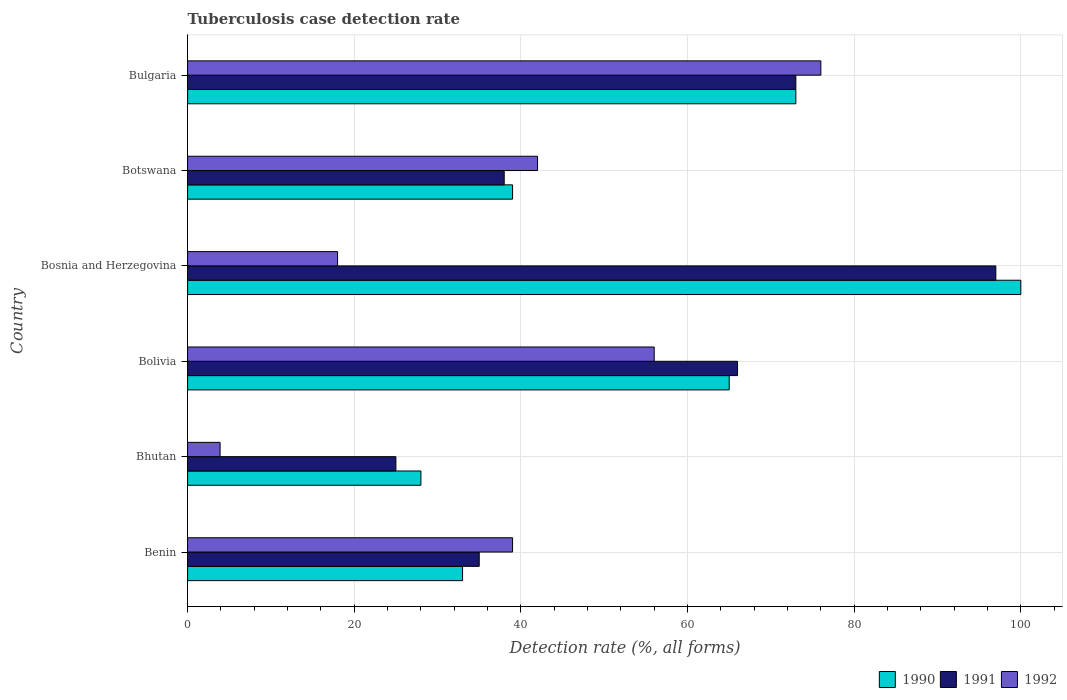How many groups of bars are there?
Provide a short and direct response. 6. Are the number of bars per tick equal to the number of legend labels?
Make the answer very short. Yes. How many bars are there on the 6th tick from the top?
Ensure brevity in your answer.  3. How many bars are there on the 4th tick from the bottom?
Keep it short and to the point. 3. What is the tuberculosis case detection rate in in 1991 in Benin?
Provide a succinct answer. 35. Across all countries, what is the maximum tuberculosis case detection rate in in 1991?
Provide a succinct answer. 97. Across all countries, what is the minimum tuberculosis case detection rate in in 1990?
Your response must be concise. 28. In which country was the tuberculosis case detection rate in in 1990 maximum?
Give a very brief answer. Bosnia and Herzegovina. In which country was the tuberculosis case detection rate in in 1992 minimum?
Offer a terse response. Bhutan. What is the total tuberculosis case detection rate in in 1992 in the graph?
Offer a very short reply. 234.9. What is the difference between the tuberculosis case detection rate in in 1990 in Benin and that in Bosnia and Herzegovina?
Offer a terse response. -67. What is the difference between the tuberculosis case detection rate in in 1991 in Bhutan and the tuberculosis case detection rate in in 1990 in Benin?
Keep it short and to the point. -8. What is the average tuberculosis case detection rate in in 1990 per country?
Your answer should be compact. 56.33. In how many countries, is the tuberculosis case detection rate in in 1990 greater than 56 %?
Keep it short and to the point. 3. What is the ratio of the tuberculosis case detection rate in in 1990 in Benin to that in Bosnia and Herzegovina?
Provide a short and direct response. 0.33. Is the tuberculosis case detection rate in in 1992 in Benin less than that in Botswana?
Provide a short and direct response. Yes. What is the difference between the highest and the second highest tuberculosis case detection rate in in 1990?
Offer a very short reply. 27. What is the difference between the highest and the lowest tuberculosis case detection rate in in 1992?
Provide a short and direct response. 72.1. Is the sum of the tuberculosis case detection rate in in 1991 in Benin and Bosnia and Herzegovina greater than the maximum tuberculosis case detection rate in in 1992 across all countries?
Provide a short and direct response. Yes. How many bars are there?
Your response must be concise. 18. Are all the bars in the graph horizontal?
Provide a short and direct response. Yes. What is the difference between two consecutive major ticks on the X-axis?
Provide a short and direct response. 20. Are the values on the major ticks of X-axis written in scientific E-notation?
Provide a short and direct response. No. How many legend labels are there?
Offer a very short reply. 3. How are the legend labels stacked?
Offer a terse response. Horizontal. What is the title of the graph?
Provide a succinct answer. Tuberculosis case detection rate. Does "1973" appear as one of the legend labels in the graph?
Ensure brevity in your answer.  No. What is the label or title of the X-axis?
Ensure brevity in your answer.  Detection rate (%, all forms). What is the Detection rate (%, all forms) of 1991 in Benin?
Keep it short and to the point. 35. What is the Detection rate (%, all forms) of 1992 in Benin?
Ensure brevity in your answer.  39. What is the Detection rate (%, all forms) in 1990 in Bhutan?
Give a very brief answer. 28. What is the Detection rate (%, all forms) of 1992 in Bolivia?
Offer a terse response. 56. What is the Detection rate (%, all forms) in 1990 in Bosnia and Herzegovina?
Provide a short and direct response. 100. What is the Detection rate (%, all forms) of 1991 in Bosnia and Herzegovina?
Keep it short and to the point. 97. What is the Detection rate (%, all forms) in 1990 in Bulgaria?
Ensure brevity in your answer.  73. What is the Detection rate (%, all forms) in 1991 in Bulgaria?
Offer a very short reply. 73. What is the Detection rate (%, all forms) of 1992 in Bulgaria?
Provide a short and direct response. 76. Across all countries, what is the maximum Detection rate (%, all forms) of 1990?
Provide a succinct answer. 100. Across all countries, what is the maximum Detection rate (%, all forms) in 1991?
Your response must be concise. 97. Across all countries, what is the minimum Detection rate (%, all forms) in 1990?
Offer a terse response. 28. Across all countries, what is the minimum Detection rate (%, all forms) in 1992?
Your answer should be compact. 3.9. What is the total Detection rate (%, all forms) in 1990 in the graph?
Offer a very short reply. 338. What is the total Detection rate (%, all forms) in 1991 in the graph?
Provide a succinct answer. 334. What is the total Detection rate (%, all forms) in 1992 in the graph?
Ensure brevity in your answer.  234.9. What is the difference between the Detection rate (%, all forms) in 1990 in Benin and that in Bhutan?
Your answer should be compact. 5. What is the difference between the Detection rate (%, all forms) of 1992 in Benin and that in Bhutan?
Your answer should be compact. 35.1. What is the difference between the Detection rate (%, all forms) in 1990 in Benin and that in Bolivia?
Offer a very short reply. -32. What is the difference between the Detection rate (%, all forms) of 1991 in Benin and that in Bolivia?
Offer a terse response. -31. What is the difference between the Detection rate (%, all forms) in 1990 in Benin and that in Bosnia and Herzegovina?
Your answer should be very brief. -67. What is the difference between the Detection rate (%, all forms) in 1991 in Benin and that in Bosnia and Herzegovina?
Offer a very short reply. -62. What is the difference between the Detection rate (%, all forms) of 1992 in Benin and that in Bosnia and Herzegovina?
Offer a very short reply. 21. What is the difference between the Detection rate (%, all forms) in 1990 in Benin and that in Botswana?
Provide a succinct answer. -6. What is the difference between the Detection rate (%, all forms) of 1991 in Benin and that in Bulgaria?
Your response must be concise. -38. What is the difference between the Detection rate (%, all forms) in 1992 in Benin and that in Bulgaria?
Ensure brevity in your answer.  -37. What is the difference between the Detection rate (%, all forms) in 1990 in Bhutan and that in Bolivia?
Keep it short and to the point. -37. What is the difference between the Detection rate (%, all forms) in 1991 in Bhutan and that in Bolivia?
Provide a short and direct response. -41. What is the difference between the Detection rate (%, all forms) of 1992 in Bhutan and that in Bolivia?
Your answer should be very brief. -52.1. What is the difference between the Detection rate (%, all forms) in 1990 in Bhutan and that in Bosnia and Herzegovina?
Provide a short and direct response. -72. What is the difference between the Detection rate (%, all forms) of 1991 in Bhutan and that in Bosnia and Herzegovina?
Your answer should be very brief. -72. What is the difference between the Detection rate (%, all forms) in 1992 in Bhutan and that in Bosnia and Herzegovina?
Offer a terse response. -14.1. What is the difference between the Detection rate (%, all forms) of 1990 in Bhutan and that in Botswana?
Your answer should be compact. -11. What is the difference between the Detection rate (%, all forms) of 1991 in Bhutan and that in Botswana?
Keep it short and to the point. -13. What is the difference between the Detection rate (%, all forms) of 1992 in Bhutan and that in Botswana?
Make the answer very short. -38.1. What is the difference between the Detection rate (%, all forms) of 1990 in Bhutan and that in Bulgaria?
Offer a very short reply. -45. What is the difference between the Detection rate (%, all forms) in 1991 in Bhutan and that in Bulgaria?
Offer a terse response. -48. What is the difference between the Detection rate (%, all forms) of 1992 in Bhutan and that in Bulgaria?
Make the answer very short. -72.1. What is the difference between the Detection rate (%, all forms) in 1990 in Bolivia and that in Bosnia and Herzegovina?
Your answer should be compact. -35. What is the difference between the Detection rate (%, all forms) in 1991 in Bolivia and that in Bosnia and Herzegovina?
Keep it short and to the point. -31. What is the difference between the Detection rate (%, all forms) in 1992 in Bolivia and that in Bosnia and Herzegovina?
Your answer should be very brief. 38. What is the difference between the Detection rate (%, all forms) of 1990 in Bolivia and that in Botswana?
Ensure brevity in your answer.  26. What is the difference between the Detection rate (%, all forms) of 1990 in Bolivia and that in Bulgaria?
Your answer should be compact. -8. What is the difference between the Detection rate (%, all forms) in 1991 in Bolivia and that in Bulgaria?
Your answer should be very brief. -7. What is the difference between the Detection rate (%, all forms) in 1992 in Bolivia and that in Bulgaria?
Your answer should be compact. -20. What is the difference between the Detection rate (%, all forms) in 1990 in Bosnia and Herzegovina and that in Botswana?
Keep it short and to the point. 61. What is the difference between the Detection rate (%, all forms) of 1992 in Bosnia and Herzegovina and that in Botswana?
Provide a succinct answer. -24. What is the difference between the Detection rate (%, all forms) of 1992 in Bosnia and Herzegovina and that in Bulgaria?
Offer a very short reply. -58. What is the difference between the Detection rate (%, all forms) in 1990 in Botswana and that in Bulgaria?
Make the answer very short. -34. What is the difference between the Detection rate (%, all forms) of 1991 in Botswana and that in Bulgaria?
Keep it short and to the point. -35. What is the difference between the Detection rate (%, all forms) in 1992 in Botswana and that in Bulgaria?
Offer a terse response. -34. What is the difference between the Detection rate (%, all forms) of 1990 in Benin and the Detection rate (%, all forms) of 1991 in Bhutan?
Provide a succinct answer. 8. What is the difference between the Detection rate (%, all forms) in 1990 in Benin and the Detection rate (%, all forms) in 1992 in Bhutan?
Provide a succinct answer. 29.1. What is the difference between the Detection rate (%, all forms) in 1991 in Benin and the Detection rate (%, all forms) in 1992 in Bhutan?
Offer a terse response. 31.1. What is the difference between the Detection rate (%, all forms) in 1990 in Benin and the Detection rate (%, all forms) in 1991 in Bolivia?
Offer a terse response. -33. What is the difference between the Detection rate (%, all forms) in 1991 in Benin and the Detection rate (%, all forms) in 1992 in Bolivia?
Keep it short and to the point. -21. What is the difference between the Detection rate (%, all forms) of 1990 in Benin and the Detection rate (%, all forms) of 1991 in Bosnia and Herzegovina?
Provide a short and direct response. -64. What is the difference between the Detection rate (%, all forms) in 1990 in Benin and the Detection rate (%, all forms) in 1991 in Botswana?
Offer a very short reply. -5. What is the difference between the Detection rate (%, all forms) in 1991 in Benin and the Detection rate (%, all forms) in 1992 in Botswana?
Give a very brief answer. -7. What is the difference between the Detection rate (%, all forms) in 1990 in Benin and the Detection rate (%, all forms) in 1991 in Bulgaria?
Your response must be concise. -40. What is the difference between the Detection rate (%, all forms) of 1990 in Benin and the Detection rate (%, all forms) of 1992 in Bulgaria?
Ensure brevity in your answer.  -43. What is the difference between the Detection rate (%, all forms) in 1991 in Benin and the Detection rate (%, all forms) in 1992 in Bulgaria?
Your answer should be very brief. -41. What is the difference between the Detection rate (%, all forms) in 1990 in Bhutan and the Detection rate (%, all forms) in 1991 in Bolivia?
Ensure brevity in your answer.  -38. What is the difference between the Detection rate (%, all forms) in 1990 in Bhutan and the Detection rate (%, all forms) in 1992 in Bolivia?
Offer a terse response. -28. What is the difference between the Detection rate (%, all forms) of 1991 in Bhutan and the Detection rate (%, all forms) of 1992 in Bolivia?
Offer a terse response. -31. What is the difference between the Detection rate (%, all forms) of 1990 in Bhutan and the Detection rate (%, all forms) of 1991 in Bosnia and Herzegovina?
Give a very brief answer. -69. What is the difference between the Detection rate (%, all forms) of 1990 in Bhutan and the Detection rate (%, all forms) of 1991 in Botswana?
Make the answer very short. -10. What is the difference between the Detection rate (%, all forms) of 1990 in Bhutan and the Detection rate (%, all forms) of 1991 in Bulgaria?
Give a very brief answer. -45. What is the difference between the Detection rate (%, all forms) of 1990 in Bhutan and the Detection rate (%, all forms) of 1992 in Bulgaria?
Your answer should be compact. -48. What is the difference between the Detection rate (%, all forms) of 1991 in Bhutan and the Detection rate (%, all forms) of 1992 in Bulgaria?
Ensure brevity in your answer.  -51. What is the difference between the Detection rate (%, all forms) in 1990 in Bolivia and the Detection rate (%, all forms) in 1991 in Bosnia and Herzegovina?
Provide a succinct answer. -32. What is the difference between the Detection rate (%, all forms) in 1991 in Bolivia and the Detection rate (%, all forms) in 1992 in Bosnia and Herzegovina?
Keep it short and to the point. 48. What is the difference between the Detection rate (%, all forms) in 1990 in Bolivia and the Detection rate (%, all forms) in 1991 in Botswana?
Offer a terse response. 27. What is the difference between the Detection rate (%, all forms) in 1990 in Bolivia and the Detection rate (%, all forms) in 1992 in Bulgaria?
Your answer should be very brief. -11. What is the difference between the Detection rate (%, all forms) in 1991 in Bolivia and the Detection rate (%, all forms) in 1992 in Bulgaria?
Your answer should be very brief. -10. What is the difference between the Detection rate (%, all forms) in 1990 in Bosnia and Herzegovina and the Detection rate (%, all forms) in 1992 in Botswana?
Your answer should be compact. 58. What is the difference between the Detection rate (%, all forms) of 1991 in Bosnia and Herzegovina and the Detection rate (%, all forms) of 1992 in Bulgaria?
Give a very brief answer. 21. What is the difference between the Detection rate (%, all forms) of 1990 in Botswana and the Detection rate (%, all forms) of 1991 in Bulgaria?
Offer a very short reply. -34. What is the difference between the Detection rate (%, all forms) in 1990 in Botswana and the Detection rate (%, all forms) in 1992 in Bulgaria?
Ensure brevity in your answer.  -37. What is the difference between the Detection rate (%, all forms) of 1991 in Botswana and the Detection rate (%, all forms) of 1992 in Bulgaria?
Keep it short and to the point. -38. What is the average Detection rate (%, all forms) in 1990 per country?
Your response must be concise. 56.33. What is the average Detection rate (%, all forms) in 1991 per country?
Your answer should be compact. 55.67. What is the average Detection rate (%, all forms) in 1992 per country?
Give a very brief answer. 39.15. What is the difference between the Detection rate (%, all forms) of 1990 and Detection rate (%, all forms) of 1992 in Benin?
Offer a very short reply. -6. What is the difference between the Detection rate (%, all forms) of 1991 and Detection rate (%, all forms) of 1992 in Benin?
Your answer should be compact. -4. What is the difference between the Detection rate (%, all forms) of 1990 and Detection rate (%, all forms) of 1991 in Bhutan?
Keep it short and to the point. 3. What is the difference between the Detection rate (%, all forms) of 1990 and Detection rate (%, all forms) of 1992 in Bhutan?
Provide a succinct answer. 24.1. What is the difference between the Detection rate (%, all forms) in 1991 and Detection rate (%, all forms) in 1992 in Bhutan?
Make the answer very short. 21.1. What is the difference between the Detection rate (%, all forms) of 1990 and Detection rate (%, all forms) of 1991 in Bolivia?
Give a very brief answer. -1. What is the difference between the Detection rate (%, all forms) of 1991 and Detection rate (%, all forms) of 1992 in Bolivia?
Provide a succinct answer. 10. What is the difference between the Detection rate (%, all forms) of 1991 and Detection rate (%, all forms) of 1992 in Bosnia and Herzegovina?
Give a very brief answer. 79. What is the difference between the Detection rate (%, all forms) of 1990 and Detection rate (%, all forms) of 1991 in Botswana?
Offer a terse response. 1. What is the difference between the Detection rate (%, all forms) in 1990 and Detection rate (%, all forms) in 1991 in Bulgaria?
Keep it short and to the point. 0. What is the ratio of the Detection rate (%, all forms) of 1990 in Benin to that in Bhutan?
Your answer should be very brief. 1.18. What is the ratio of the Detection rate (%, all forms) of 1992 in Benin to that in Bhutan?
Your response must be concise. 10. What is the ratio of the Detection rate (%, all forms) of 1990 in Benin to that in Bolivia?
Give a very brief answer. 0.51. What is the ratio of the Detection rate (%, all forms) of 1991 in Benin to that in Bolivia?
Your answer should be very brief. 0.53. What is the ratio of the Detection rate (%, all forms) of 1992 in Benin to that in Bolivia?
Your answer should be very brief. 0.7. What is the ratio of the Detection rate (%, all forms) in 1990 in Benin to that in Bosnia and Herzegovina?
Offer a very short reply. 0.33. What is the ratio of the Detection rate (%, all forms) of 1991 in Benin to that in Bosnia and Herzegovina?
Provide a short and direct response. 0.36. What is the ratio of the Detection rate (%, all forms) in 1992 in Benin to that in Bosnia and Herzegovina?
Your answer should be very brief. 2.17. What is the ratio of the Detection rate (%, all forms) in 1990 in Benin to that in Botswana?
Offer a terse response. 0.85. What is the ratio of the Detection rate (%, all forms) of 1991 in Benin to that in Botswana?
Your response must be concise. 0.92. What is the ratio of the Detection rate (%, all forms) of 1990 in Benin to that in Bulgaria?
Offer a terse response. 0.45. What is the ratio of the Detection rate (%, all forms) in 1991 in Benin to that in Bulgaria?
Ensure brevity in your answer.  0.48. What is the ratio of the Detection rate (%, all forms) of 1992 in Benin to that in Bulgaria?
Keep it short and to the point. 0.51. What is the ratio of the Detection rate (%, all forms) in 1990 in Bhutan to that in Bolivia?
Give a very brief answer. 0.43. What is the ratio of the Detection rate (%, all forms) of 1991 in Bhutan to that in Bolivia?
Ensure brevity in your answer.  0.38. What is the ratio of the Detection rate (%, all forms) in 1992 in Bhutan to that in Bolivia?
Give a very brief answer. 0.07. What is the ratio of the Detection rate (%, all forms) of 1990 in Bhutan to that in Bosnia and Herzegovina?
Give a very brief answer. 0.28. What is the ratio of the Detection rate (%, all forms) of 1991 in Bhutan to that in Bosnia and Herzegovina?
Offer a very short reply. 0.26. What is the ratio of the Detection rate (%, all forms) in 1992 in Bhutan to that in Bosnia and Herzegovina?
Your answer should be very brief. 0.22. What is the ratio of the Detection rate (%, all forms) in 1990 in Bhutan to that in Botswana?
Your answer should be very brief. 0.72. What is the ratio of the Detection rate (%, all forms) in 1991 in Bhutan to that in Botswana?
Give a very brief answer. 0.66. What is the ratio of the Detection rate (%, all forms) of 1992 in Bhutan to that in Botswana?
Keep it short and to the point. 0.09. What is the ratio of the Detection rate (%, all forms) in 1990 in Bhutan to that in Bulgaria?
Keep it short and to the point. 0.38. What is the ratio of the Detection rate (%, all forms) in 1991 in Bhutan to that in Bulgaria?
Provide a short and direct response. 0.34. What is the ratio of the Detection rate (%, all forms) of 1992 in Bhutan to that in Bulgaria?
Provide a succinct answer. 0.05. What is the ratio of the Detection rate (%, all forms) of 1990 in Bolivia to that in Bosnia and Herzegovina?
Your answer should be very brief. 0.65. What is the ratio of the Detection rate (%, all forms) of 1991 in Bolivia to that in Bosnia and Herzegovina?
Make the answer very short. 0.68. What is the ratio of the Detection rate (%, all forms) of 1992 in Bolivia to that in Bosnia and Herzegovina?
Give a very brief answer. 3.11. What is the ratio of the Detection rate (%, all forms) in 1991 in Bolivia to that in Botswana?
Keep it short and to the point. 1.74. What is the ratio of the Detection rate (%, all forms) of 1990 in Bolivia to that in Bulgaria?
Your response must be concise. 0.89. What is the ratio of the Detection rate (%, all forms) of 1991 in Bolivia to that in Bulgaria?
Provide a short and direct response. 0.9. What is the ratio of the Detection rate (%, all forms) of 1992 in Bolivia to that in Bulgaria?
Your answer should be very brief. 0.74. What is the ratio of the Detection rate (%, all forms) of 1990 in Bosnia and Herzegovina to that in Botswana?
Keep it short and to the point. 2.56. What is the ratio of the Detection rate (%, all forms) in 1991 in Bosnia and Herzegovina to that in Botswana?
Keep it short and to the point. 2.55. What is the ratio of the Detection rate (%, all forms) in 1992 in Bosnia and Herzegovina to that in Botswana?
Offer a very short reply. 0.43. What is the ratio of the Detection rate (%, all forms) of 1990 in Bosnia and Herzegovina to that in Bulgaria?
Your response must be concise. 1.37. What is the ratio of the Detection rate (%, all forms) in 1991 in Bosnia and Herzegovina to that in Bulgaria?
Offer a very short reply. 1.33. What is the ratio of the Detection rate (%, all forms) of 1992 in Bosnia and Herzegovina to that in Bulgaria?
Give a very brief answer. 0.24. What is the ratio of the Detection rate (%, all forms) in 1990 in Botswana to that in Bulgaria?
Offer a terse response. 0.53. What is the ratio of the Detection rate (%, all forms) of 1991 in Botswana to that in Bulgaria?
Ensure brevity in your answer.  0.52. What is the ratio of the Detection rate (%, all forms) in 1992 in Botswana to that in Bulgaria?
Offer a very short reply. 0.55. What is the difference between the highest and the second highest Detection rate (%, all forms) in 1990?
Make the answer very short. 27. What is the difference between the highest and the second highest Detection rate (%, all forms) of 1992?
Give a very brief answer. 20. What is the difference between the highest and the lowest Detection rate (%, all forms) of 1992?
Your answer should be very brief. 72.1. 